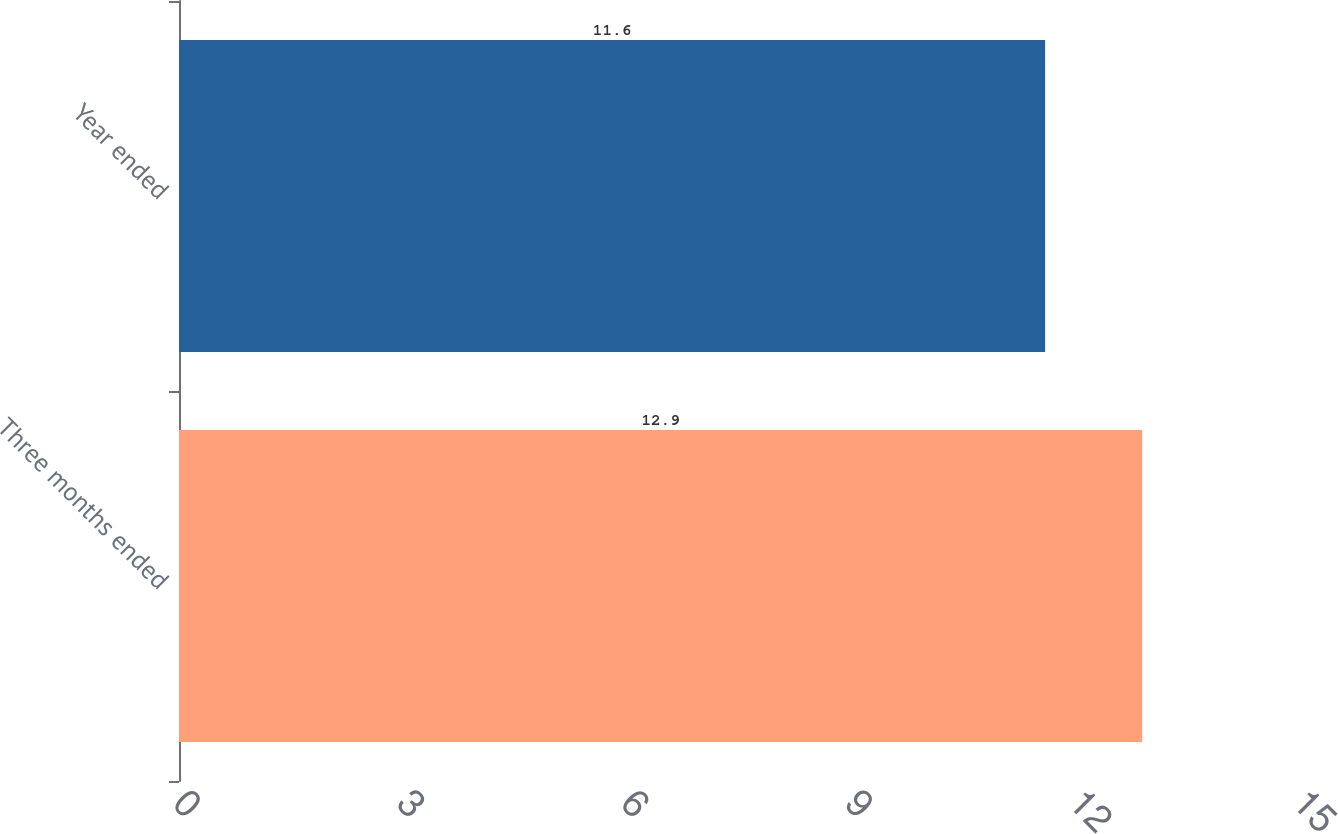<chart> <loc_0><loc_0><loc_500><loc_500><bar_chart><fcel>Three months ended<fcel>Year ended<nl><fcel>12.9<fcel>11.6<nl></chart> 